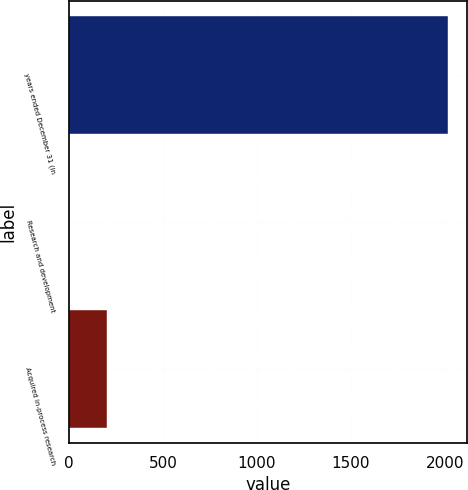Convert chart. <chart><loc_0><loc_0><loc_500><loc_500><bar_chart><fcel>years ended December 31 (in<fcel>Research and development<fcel>Acquired in-process research<nl><fcel>2016<fcel>2<fcel>203.4<nl></chart> 